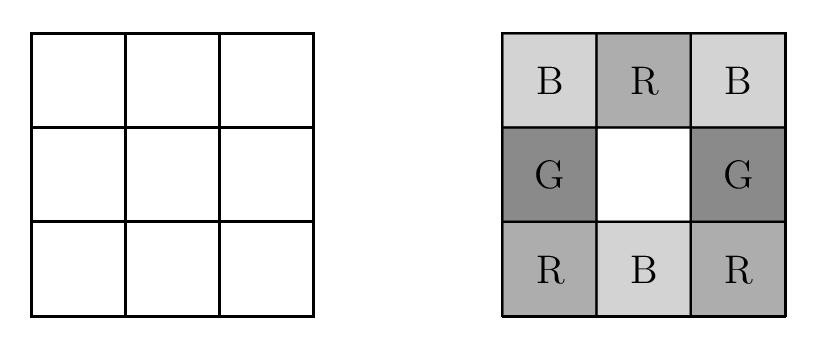What would change if another color was added to the options for coloring the grid? Adding another color, such as yellow, would increase the complexity of the problem significantly. The main challenge would be to fulfill the requirement that each $2\times 2$ square still includes one square of each color, now with five colors instead of four. This change would likely lead to a higher number of possible colorings, as there would be more combinations available for each section of the grid. It would also make the problem more computationally intense to solve, requiring deeper combinatorial analysis. 